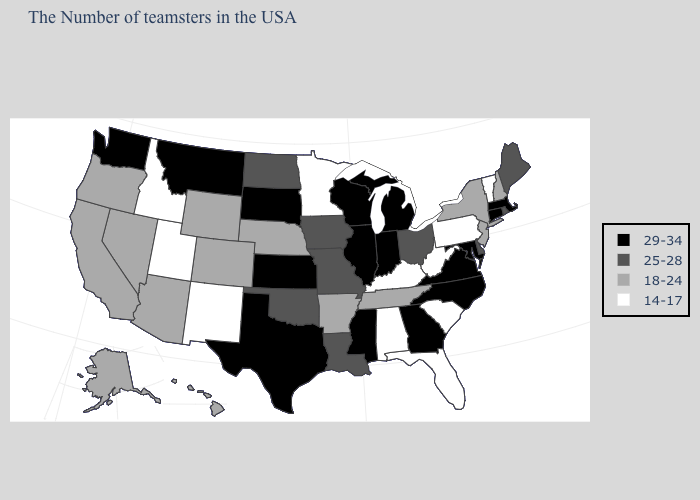Among the states that border New Jersey , which have the lowest value?
Quick response, please. Pennsylvania. Which states have the lowest value in the USA?
Answer briefly. Vermont, Pennsylvania, South Carolina, West Virginia, Florida, Kentucky, Alabama, Minnesota, New Mexico, Utah, Idaho. Which states have the lowest value in the West?
Write a very short answer. New Mexico, Utah, Idaho. What is the value of Illinois?
Short answer required. 29-34. Does Vermont have the lowest value in the USA?
Write a very short answer. Yes. Does the map have missing data?
Be succinct. No. Does the first symbol in the legend represent the smallest category?
Write a very short answer. No. Does West Virginia have the lowest value in the USA?
Answer briefly. Yes. Does Kansas have the same value as Alaska?
Be succinct. No. Among the states that border Arkansas , does Tennessee have the lowest value?
Keep it brief. Yes. What is the value of Nebraska?
Keep it brief. 18-24. Is the legend a continuous bar?
Give a very brief answer. No. What is the value of Colorado?
Write a very short answer. 18-24. Among the states that border Oregon , which have the lowest value?
Answer briefly. Idaho. What is the lowest value in states that border Maryland?
Be succinct. 14-17. 